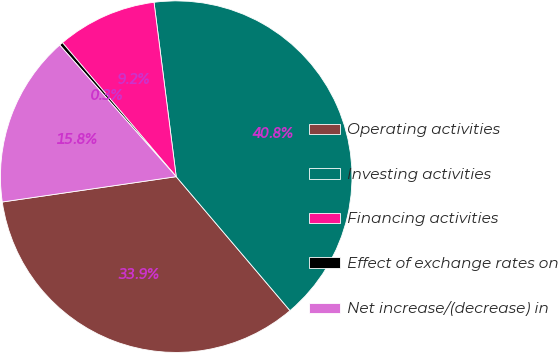<chart> <loc_0><loc_0><loc_500><loc_500><pie_chart><fcel>Operating activities<fcel>Investing activities<fcel>Financing activities<fcel>Effect of exchange rates on<fcel>Net increase/(decrease) in<nl><fcel>33.91%<fcel>40.81%<fcel>9.19%<fcel>0.33%<fcel>15.77%<nl></chart> 